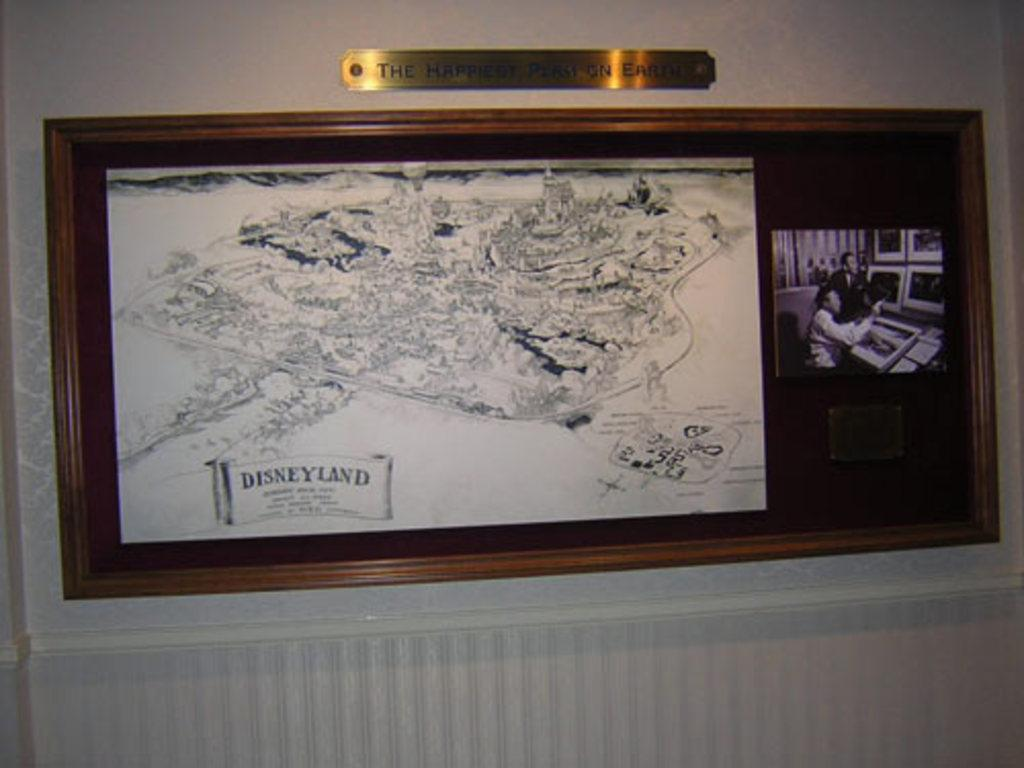What is on the wall in the image? There is a board on the wall in the image. What is depicted on the board? The board contains a map with text and a photograph. Is there any identification on the board? Yes, there is a nameplate on top of the board. What type of jelly is being served at the home in the image? There is no home or jelly present in the image; it only features a board with a map, text, photograph, and nameplate. 